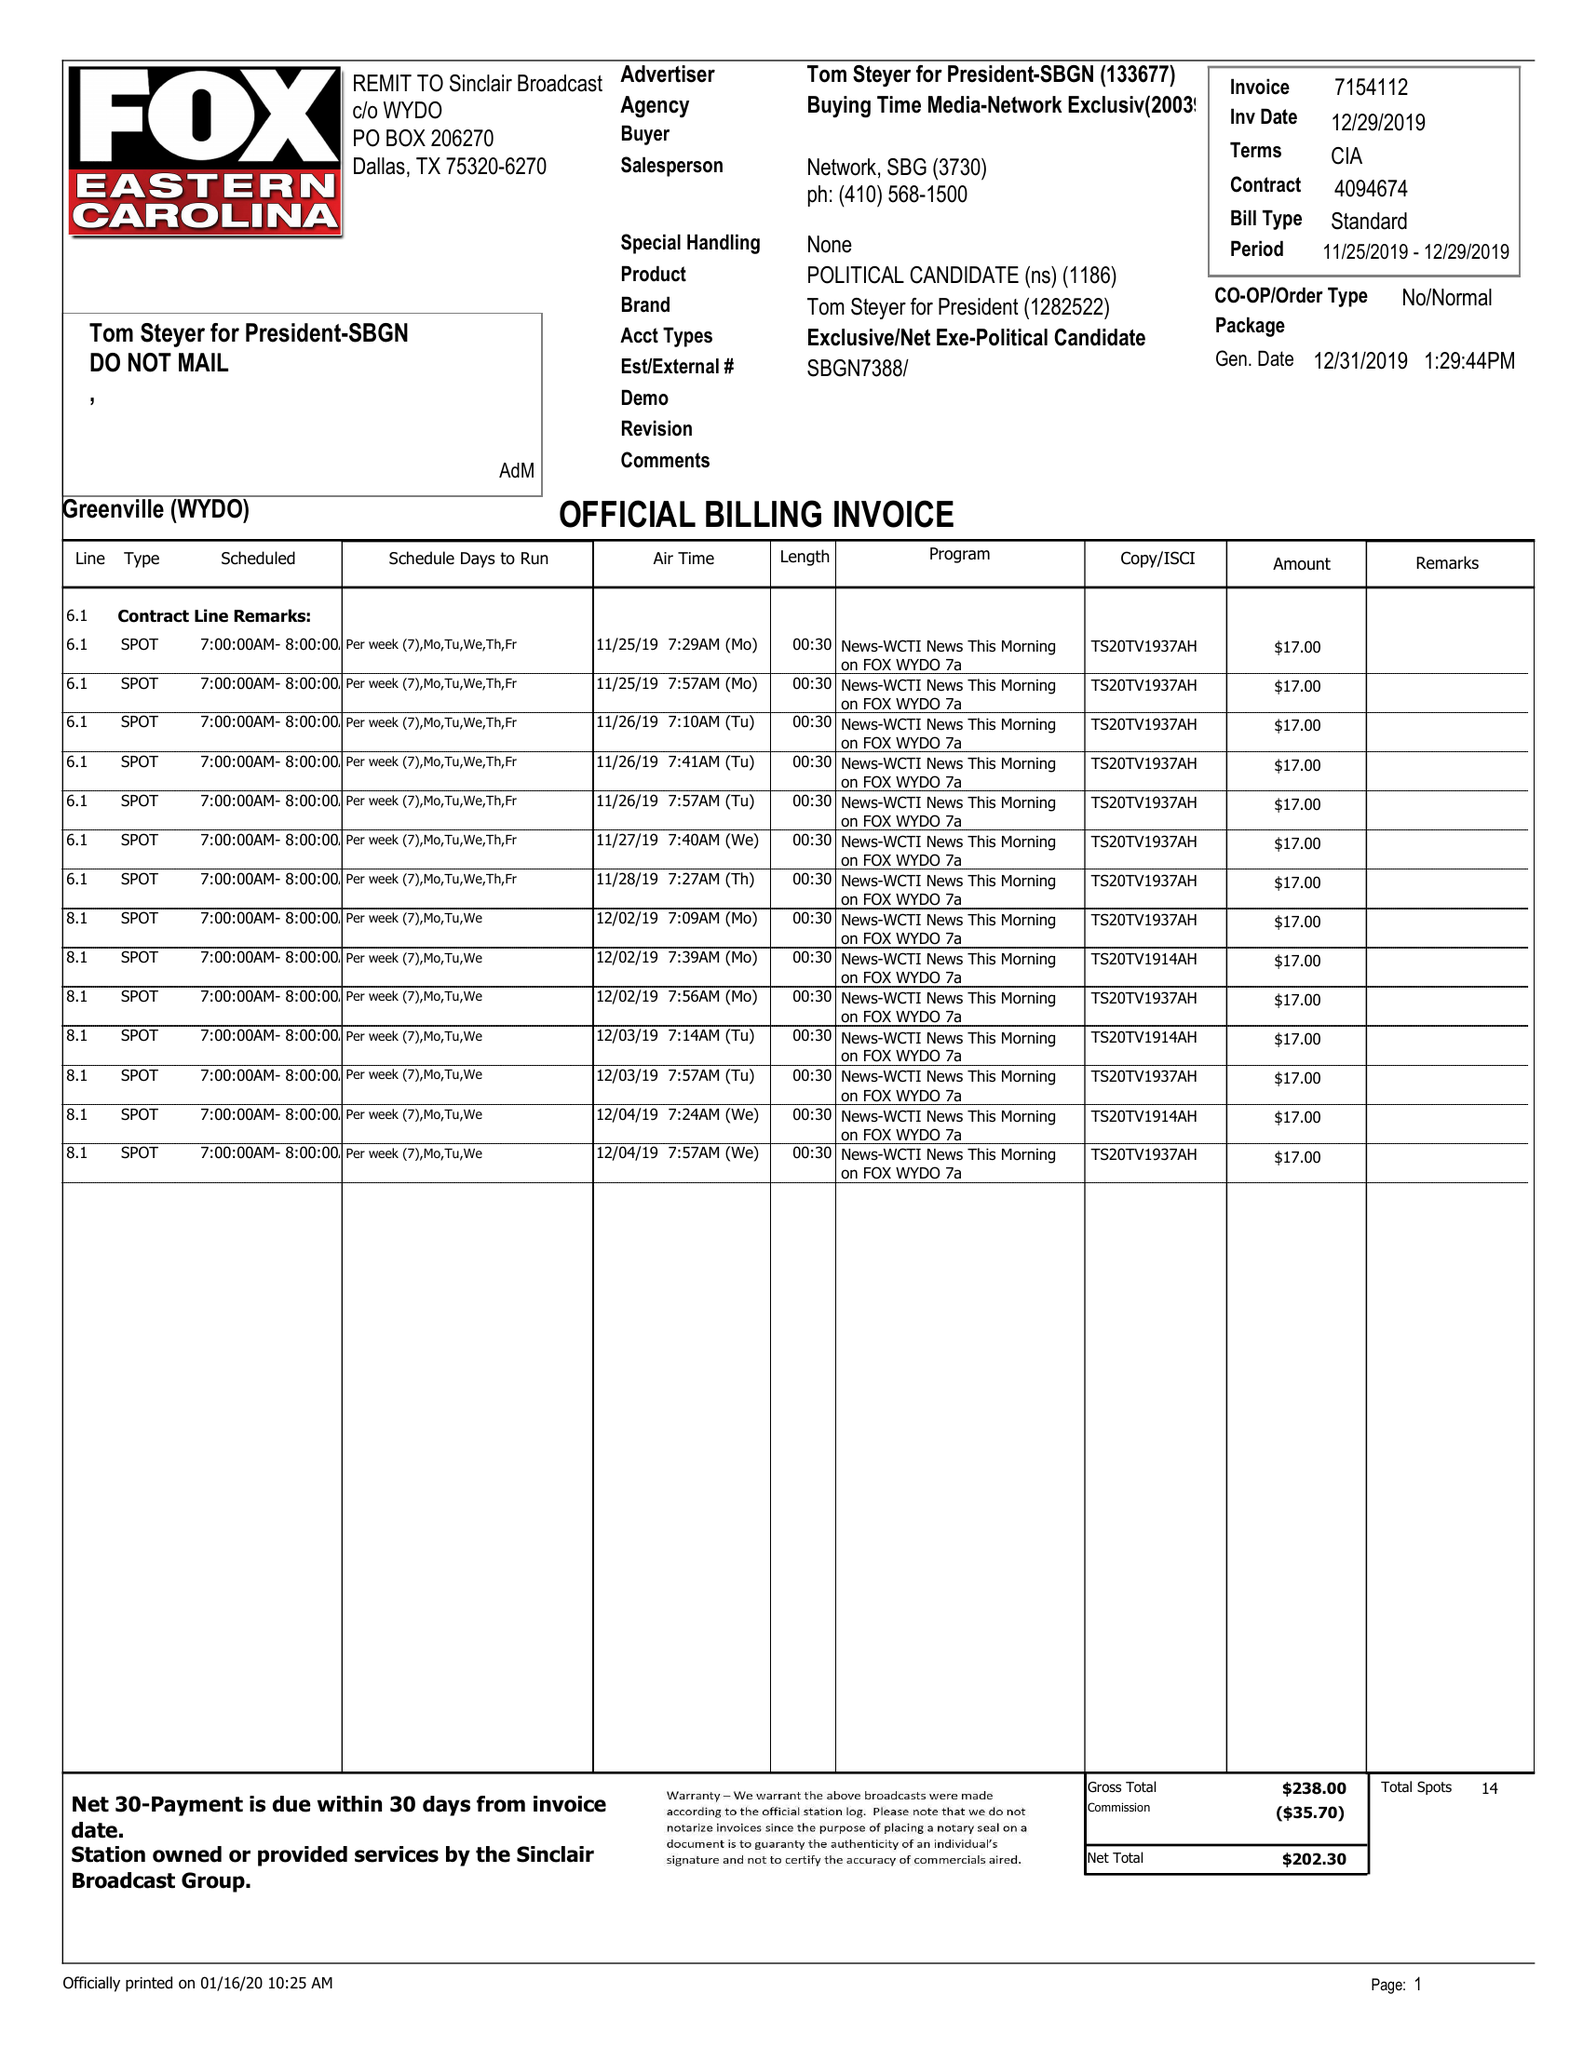What is the value for the gross_amount?
Answer the question using a single word or phrase. 238.00 